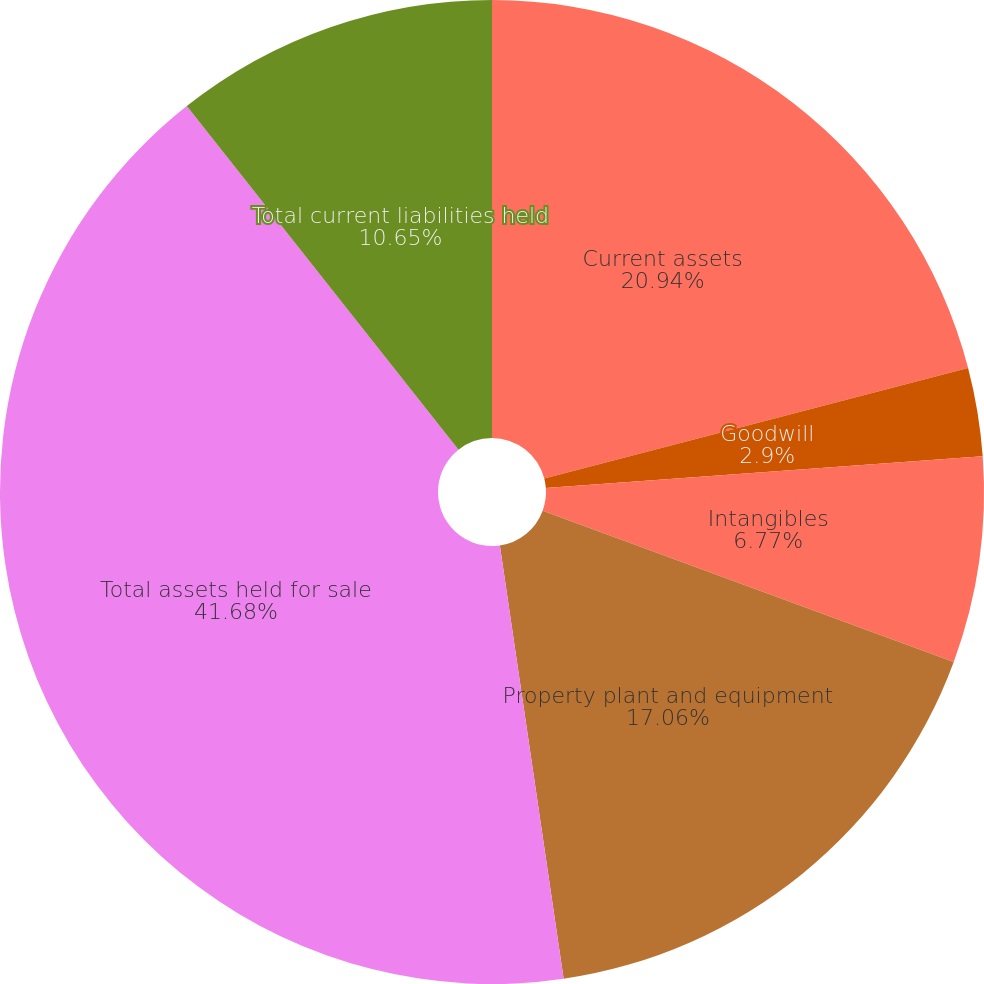Convert chart. <chart><loc_0><loc_0><loc_500><loc_500><pie_chart><fcel>Current assets<fcel>Goodwill<fcel>Intangibles<fcel>Property plant and equipment<fcel>Total assets held for sale<fcel>Total current liabilities held<nl><fcel>20.94%<fcel>2.9%<fcel>6.77%<fcel>17.06%<fcel>41.67%<fcel>10.65%<nl></chart> 